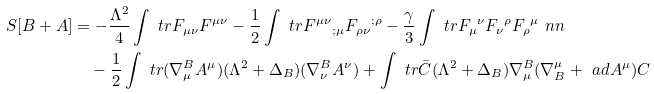Convert formula to latex. <formula><loc_0><loc_0><loc_500><loc_500>S [ B + A ] & = - \frac { \Lambda ^ { 2 } } { 4 } \int \ t r F _ { \mu \nu } F ^ { \mu \nu } - \frac { 1 } { 2 } \int \ t r { F ^ { \mu \nu } } _ { ; \mu } { F _ { \rho \nu } } ^ { ; \rho } - \frac { \gamma } { 3 } \int \ t r { F _ { \mu } } ^ { \nu } { F _ { \nu } } ^ { \rho } { F _ { \rho } } ^ { \mu } \ n n \\ & \quad - \frac { 1 } { 2 } \int \ t r ( \nabla ^ { B } _ { \mu } A ^ { \mu } ) ( \Lambda ^ { 2 } + \Delta _ { B } ) ( \nabla ^ { B } _ { \nu } A ^ { \nu } ) + \int \ t r \bar { C } ( \Lambda ^ { 2 } + \Delta _ { B } ) \nabla ^ { B } _ { \mu } ( \nabla _ { B } ^ { \mu } + \ a d A ^ { \mu } ) C</formula> 